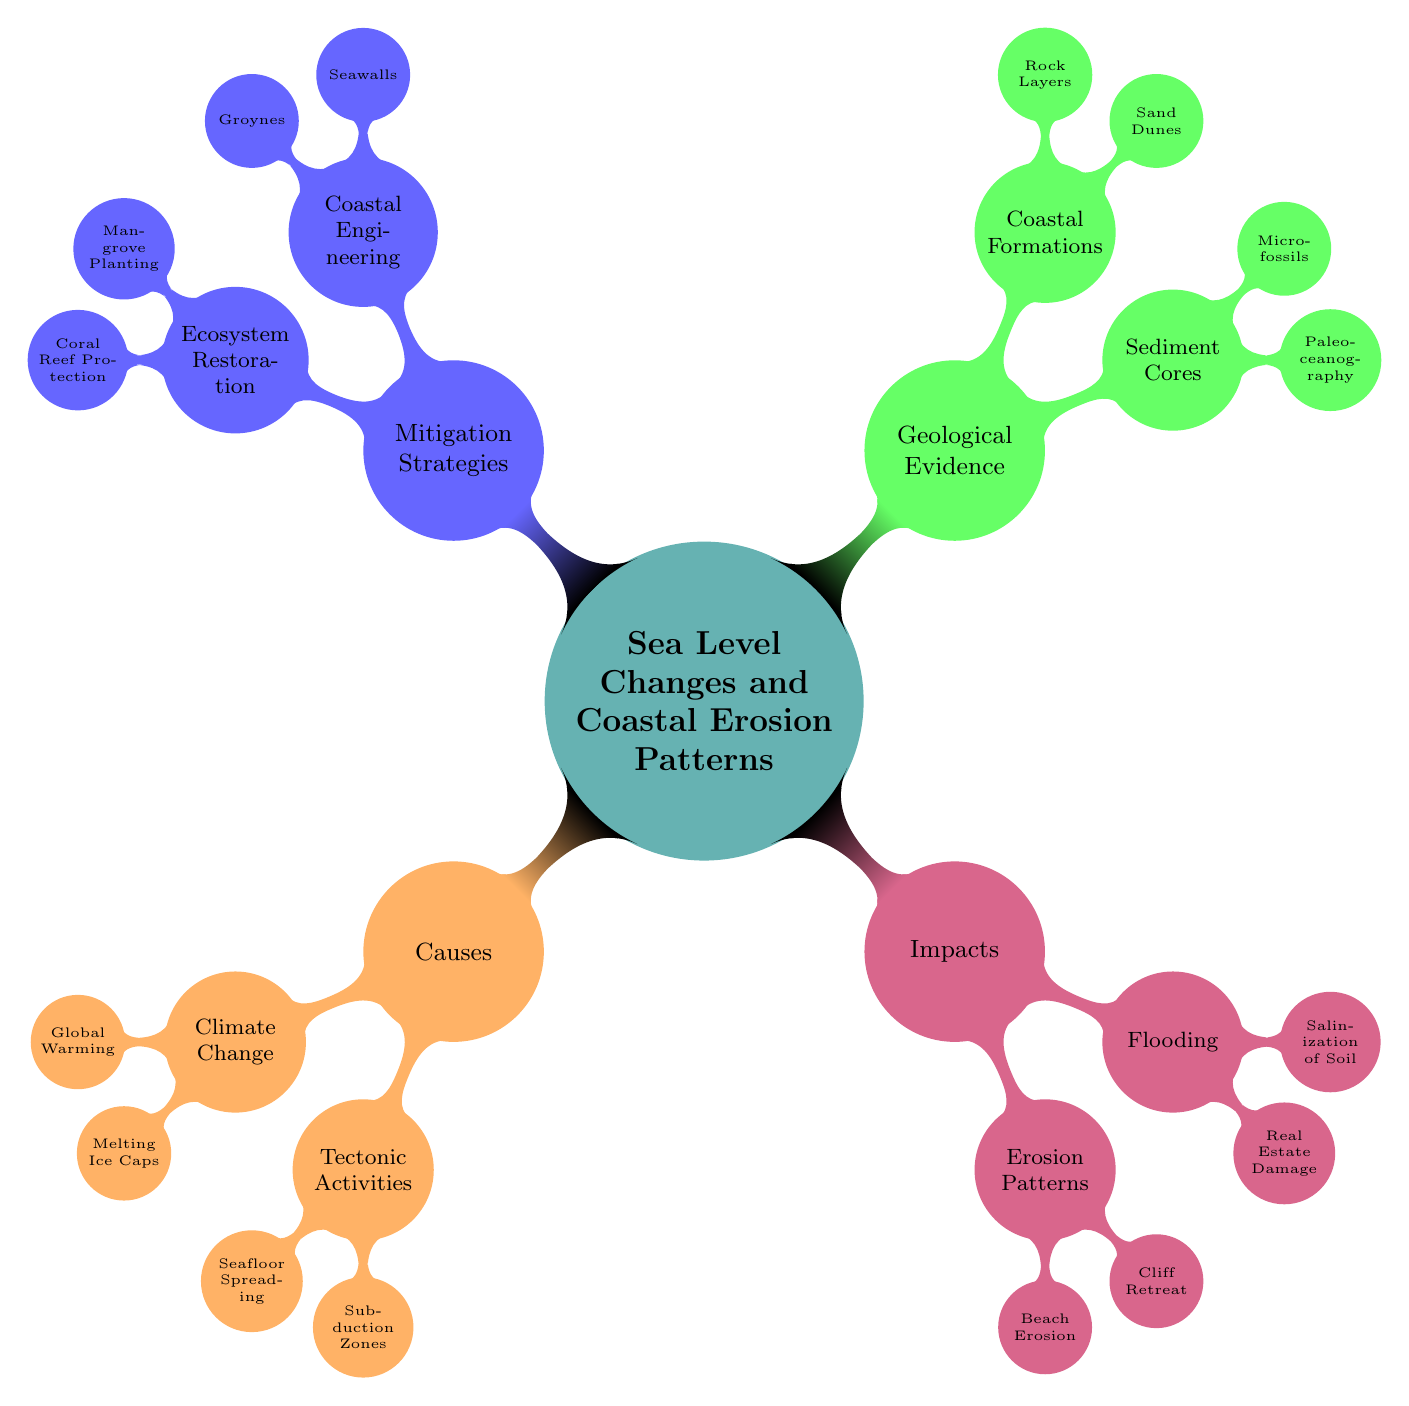What are the two primary causes of sea level changes? The diagram lists two main causes under the node "Causes": "Climate Change" and "Tectonic Activities."
Answer: Climate Change, Tectonic Activities Which strategy involves building structures to protect coastlines? The diagram shows that "Coastal Engineering" is a node under "Mitigation Strategies," which directly addresses the construction of structures like seawalls to protect coastal areas.
Answer: Coastal Engineering How many impacts are listed under the "Impacts" node? By examining the "Impacts" section, we see it has two branches: "Erosion Patterns" and "Flooding," each containing two sub-nodes, making a total of four significant impacts.
Answer: 4 What type of geological evidence is associated with Paleoceanography? The "Geological Evidence" section contains "Sediment Cores" as one of its nodes, under which "Paleoceanography" is listed as a specific type of evidence.
Answer: Sediment Cores What form of erosion is specifically mentioned under "Erosion Patterns"? The "Erosion Patterns" node contains the sub-node "Beach Erosion," which specifically addresses this type of erosion within the context of the diagram.
Answer: Beach Erosion Which ecosystem restoration activity is listed alongside coral reef protection? The diagram indicates "Mangrove Planting" is a part of "Ecosystem Restoration," which is grouped with "Coral Reef Protection" under "Mitigation Strategies."
Answer: Mangrove Planting Is real estate damage expected to have an impact from flooding? Under the "Flooding" section within "Impacts," "Real Estate Damage" is explicitly listed, indicating that it is one of the expected outcomes from flooding.
Answer: Yes How many nodes are there under the "Coastal Formations"? Looking into the "Geological Evidence" section, "Coastal Formations" has two sub-nodes: "Sand Dunes" and "Rock Layers," totaling two nodes.
Answer: 2 What climatic change is responsible for melting ice caps? The node "Melting Ice Caps" is directly listed under the "Climate Change" branch, linking it as a consequence of climate change and global warming.
Answer: Melting Ice Caps 